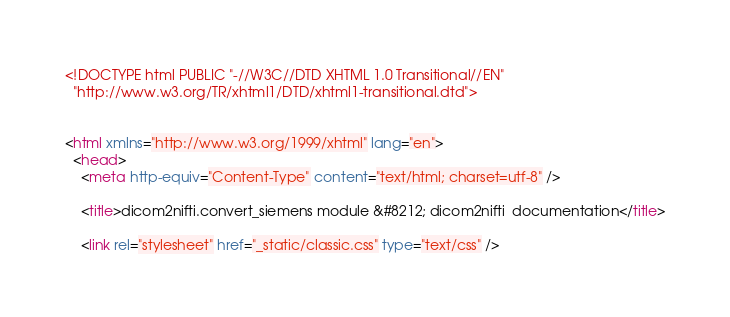Convert code to text. <code><loc_0><loc_0><loc_500><loc_500><_HTML_><!DOCTYPE html PUBLIC "-//W3C//DTD XHTML 1.0 Transitional//EN"
  "http://www.w3.org/TR/xhtml1/DTD/xhtml1-transitional.dtd">


<html xmlns="http://www.w3.org/1999/xhtml" lang="en">
  <head>
    <meta http-equiv="Content-Type" content="text/html; charset=utf-8" />
    
    <title>dicom2nifti.convert_siemens module &#8212; dicom2nifti  documentation</title>
    
    <link rel="stylesheet" href="_static/classic.css" type="text/css" /></code> 